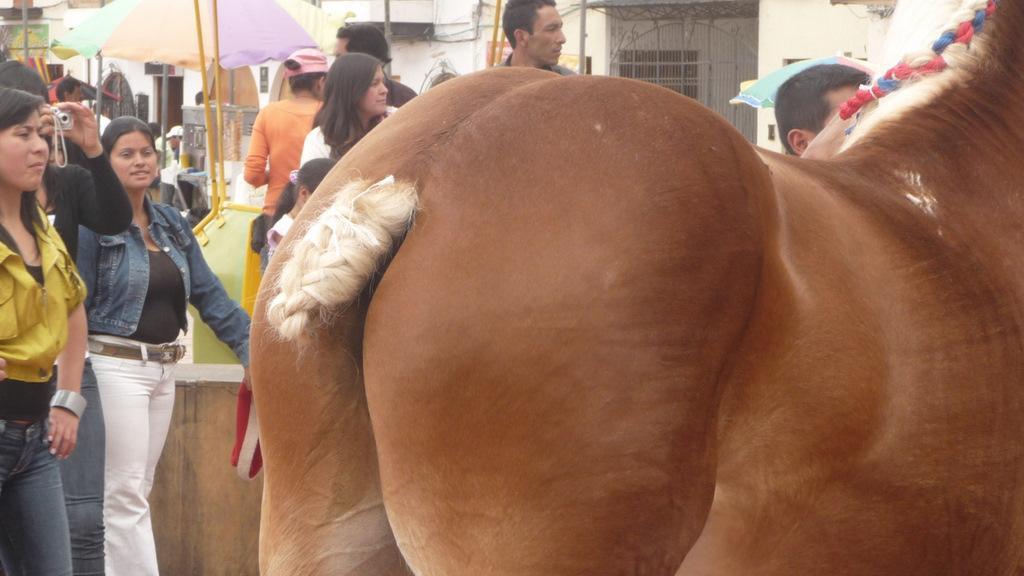Describe this image in one or two sentences. In this image, we can see an animal and people. Here a person holding a camera. Background we can see umbrellas, rods, walls, wires and few objects. 